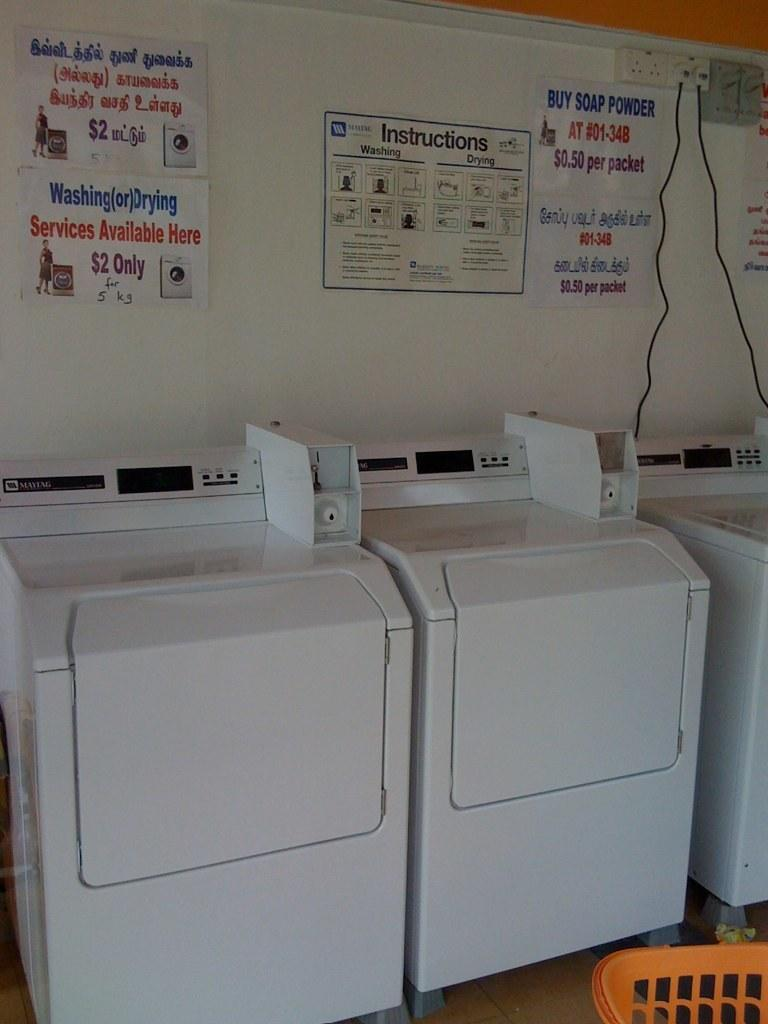What is the main subject of the image? The main subject of the image is xerox machines. Where are the xerox machines located in the image? The xerox machines are in the center of the image. What else can be seen in the background of the image? There are posters on a board in the background of the image. What is located at the bottom of the image? There is a basket at the bottom of the image. What street is visible in the image? There is no street visible in the image; it features xerox machines, posters on a board, and a basket. What is the agreement between the people in the image? There are no people visible in the image, so it is impossible to determine any agreements between them. 